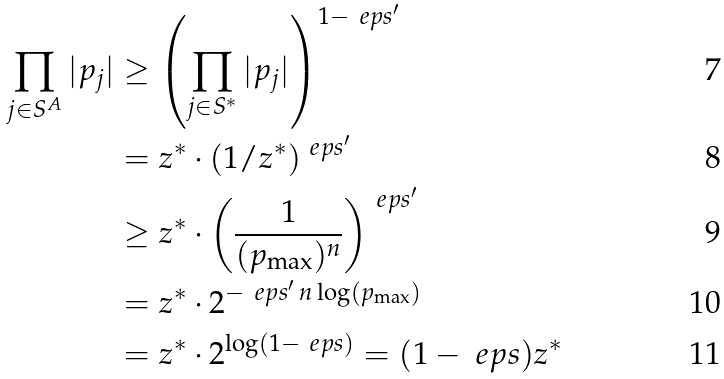<formula> <loc_0><loc_0><loc_500><loc_500>\prod _ { j \in S ^ { A } } | p _ { j } | & \geq \left ( \prod _ { j \in S ^ { * } } | p _ { j } | \right ) ^ { 1 - \ e p s ^ { \prime } } \\ & = z ^ { * } \cdot ( 1 / z ^ { * } ) ^ { \ e p s ^ { \prime } } \\ \, & \geq z ^ { * } \cdot \left ( \frac { 1 } { ( p _ { \max } ) ^ { n } } \right ) ^ { \ e p s ^ { \prime } } \\ \, & = z ^ { * } \cdot 2 ^ { - \ e p s ^ { \prime } \, n \log ( p _ { \max } ) } \\ \, & = z ^ { * } \cdot 2 ^ { \log ( 1 - \ e p s ) } = ( 1 - \ e p s ) z ^ { * }</formula> 